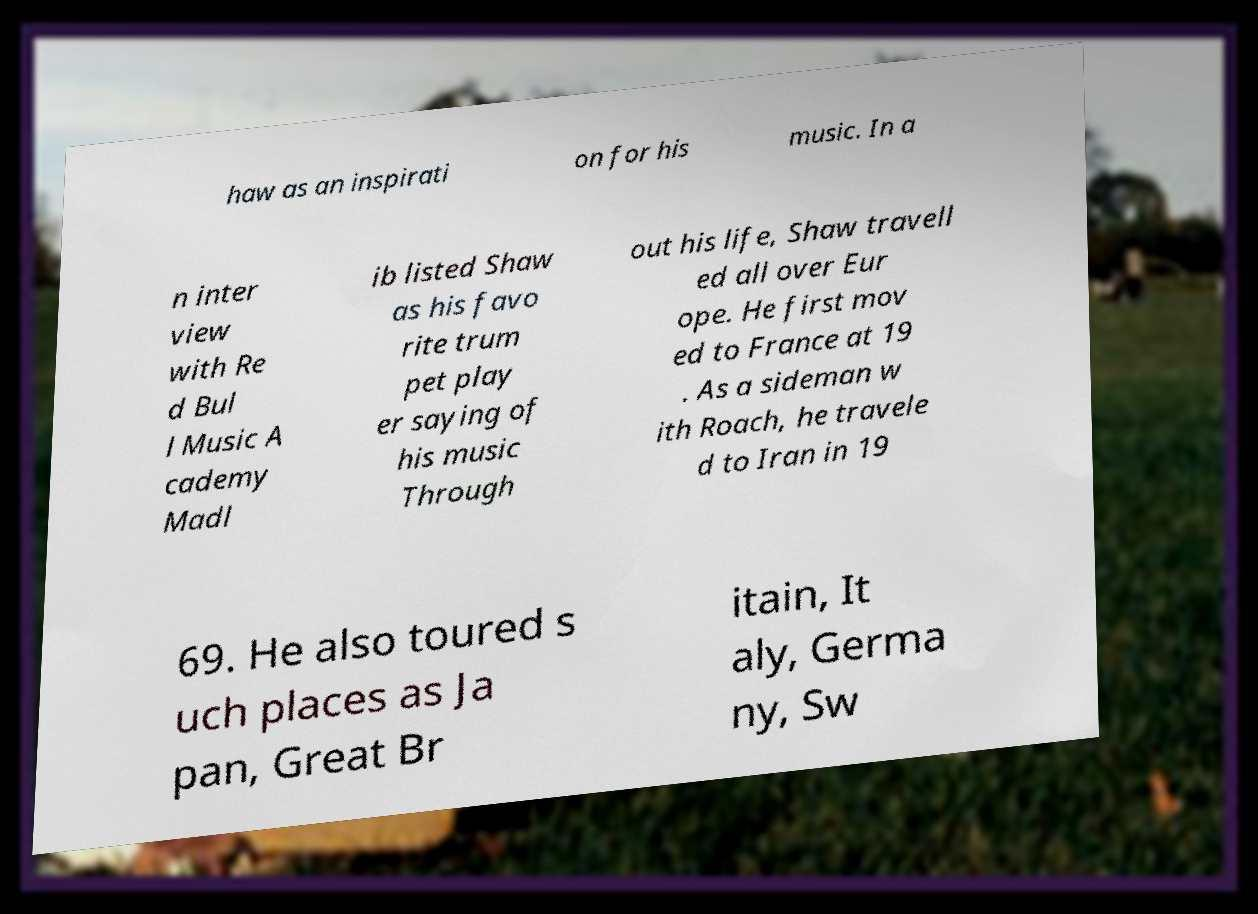I need the written content from this picture converted into text. Can you do that? haw as an inspirati on for his music. In a n inter view with Re d Bul l Music A cademy Madl ib listed Shaw as his favo rite trum pet play er saying of his music Through out his life, Shaw travell ed all over Eur ope. He first mov ed to France at 19 . As a sideman w ith Roach, he travele d to Iran in 19 69. He also toured s uch places as Ja pan, Great Br itain, It aly, Germa ny, Sw 